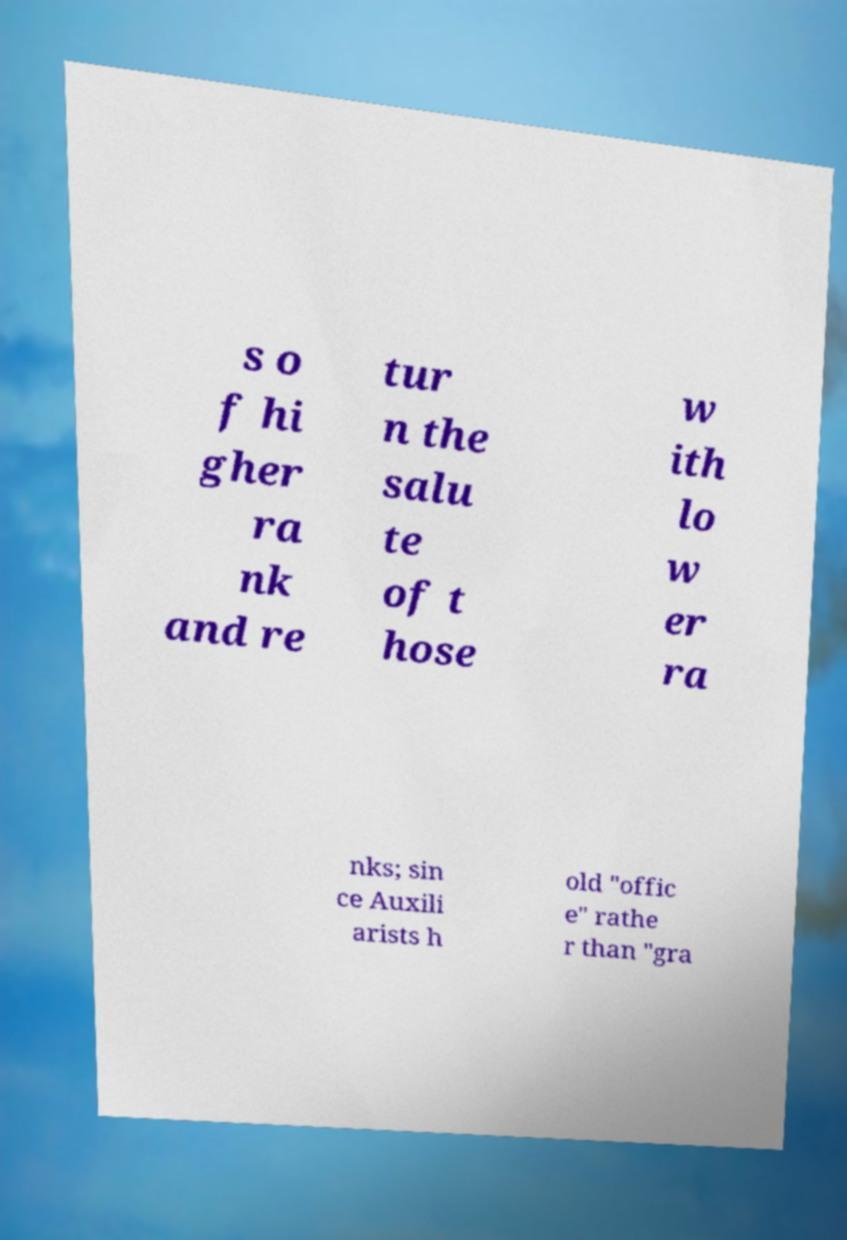Please read and relay the text visible in this image. What does it say? s o f hi gher ra nk and re tur n the salu te of t hose w ith lo w er ra nks; sin ce Auxili arists h old "offic e" rathe r than "gra 